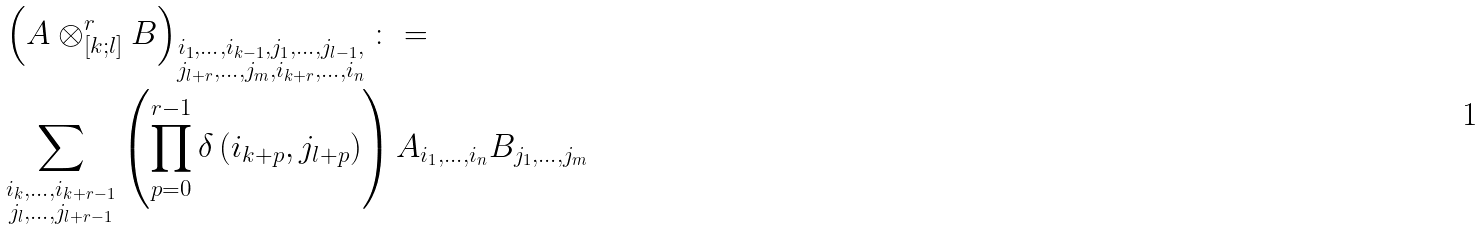Convert formula to latex. <formula><loc_0><loc_0><loc_500><loc_500>& \left ( A \otimes _ { [ k ; l ] } ^ { r } B \right ) _ { \substack { i _ { 1 } , \dots , i _ { k - 1 } , j _ { 1 } , \dots , j _ { l - 1 } , \\ j _ { l + r } , \dots , j _ { m } , i _ { k + r } , \dots , i _ { n } } } \colon = \\ & \sum _ { \substack { i _ { k } , \dots , i _ { k + r - 1 } \\ j _ { l } , \dots , j _ { l + r - 1 } } } \left ( \prod _ { p = 0 } ^ { r - 1 } \delta \left ( i _ { k + p } , j _ { l + p } \right ) \right ) A _ { i _ { 1 } , \dots , i _ { n } } B _ { j _ { 1 } , \dots , j _ { m } }</formula> 